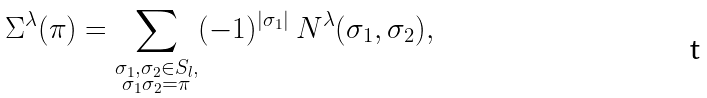Convert formula to latex. <formula><loc_0><loc_0><loc_500><loc_500>\Sigma ^ { \lambda } ( \pi ) = \sum _ { \substack { \sigma _ { 1 } , \sigma _ { 2 } \in S _ { l } , \\ \sigma _ { 1 } \sigma _ { 2 } = \pi } } ( - 1 ) ^ { | \sigma _ { 1 } | } \ N ^ { \lambda } ( \sigma _ { 1 } , \sigma _ { 2 } ) ,</formula> 